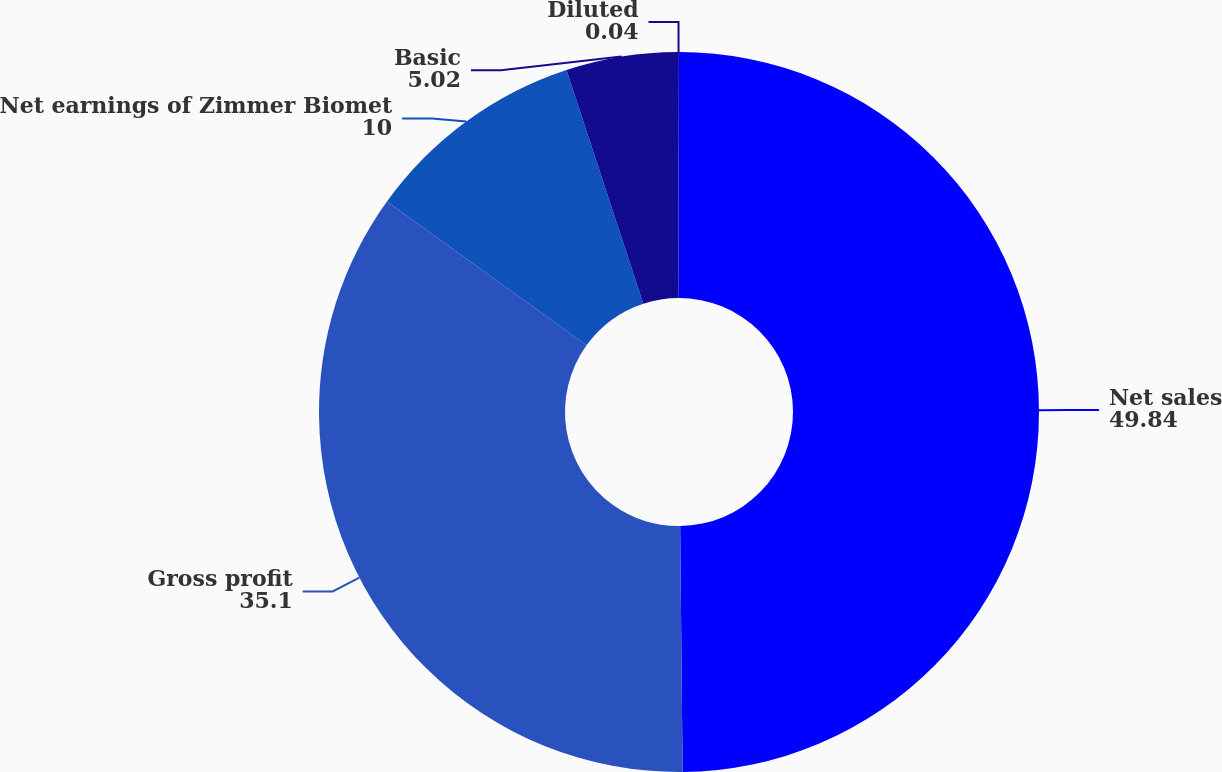Convert chart. <chart><loc_0><loc_0><loc_500><loc_500><pie_chart><fcel>Net sales<fcel>Gross profit<fcel>Net earnings of Zimmer Biomet<fcel>Basic<fcel>Diluted<nl><fcel>49.84%<fcel>35.1%<fcel>10.0%<fcel>5.02%<fcel>0.04%<nl></chart> 